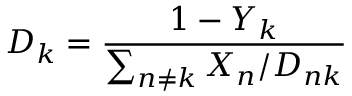<formula> <loc_0><loc_0><loc_500><loc_500>D _ { k } = \frac { 1 - Y _ { k } } { \sum _ { n \neq k } X _ { n } / D _ { n k } }</formula> 